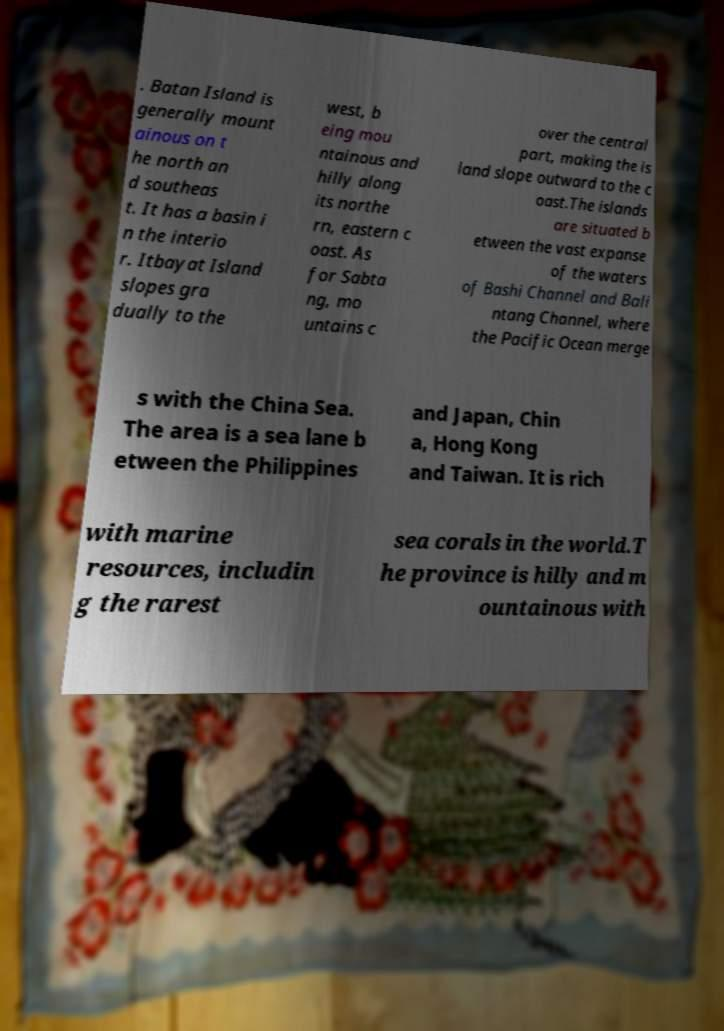Can you read and provide the text displayed in the image?This photo seems to have some interesting text. Can you extract and type it out for me? . Batan Island is generally mount ainous on t he north an d southeas t. It has a basin i n the interio r. Itbayat Island slopes gra dually to the west, b eing mou ntainous and hilly along its northe rn, eastern c oast. As for Sabta ng, mo untains c over the central part, making the is land slope outward to the c oast.The islands are situated b etween the vast expanse of the waters of Bashi Channel and Bali ntang Channel, where the Pacific Ocean merge s with the China Sea. The area is a sea lane b etween the Philippines and Japan, Chin a, Hong Kong and Taiwan. It is rich with marine resources, includin g the rarest sea corals in the world.T he province is hilly and m ountainous with 